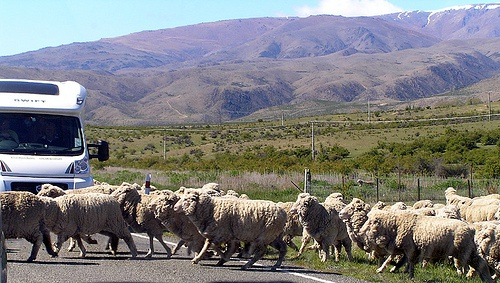Describe the objects in this image and their specific colors. I can see sheep in lightblue, black, darkgray, gray, and ivory tones, bus in lightblue, black, white, and gray tones, truck in lightblue, black, white, and gray tones, sheep in lightblue, black, ivory, and gray tones, and sheep in lightblue, black, beige, and tan tones in this image. 